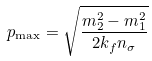<formula> <loc_0><loc_0><loc_500><loc_500>p _ { \max } = \sqrt { \frac { m ^ { 2 } _ { 2 } - m ^ { 2 } _ { 1 } } { 2 k _ { f } n _ { \sigma } } }</formula> 